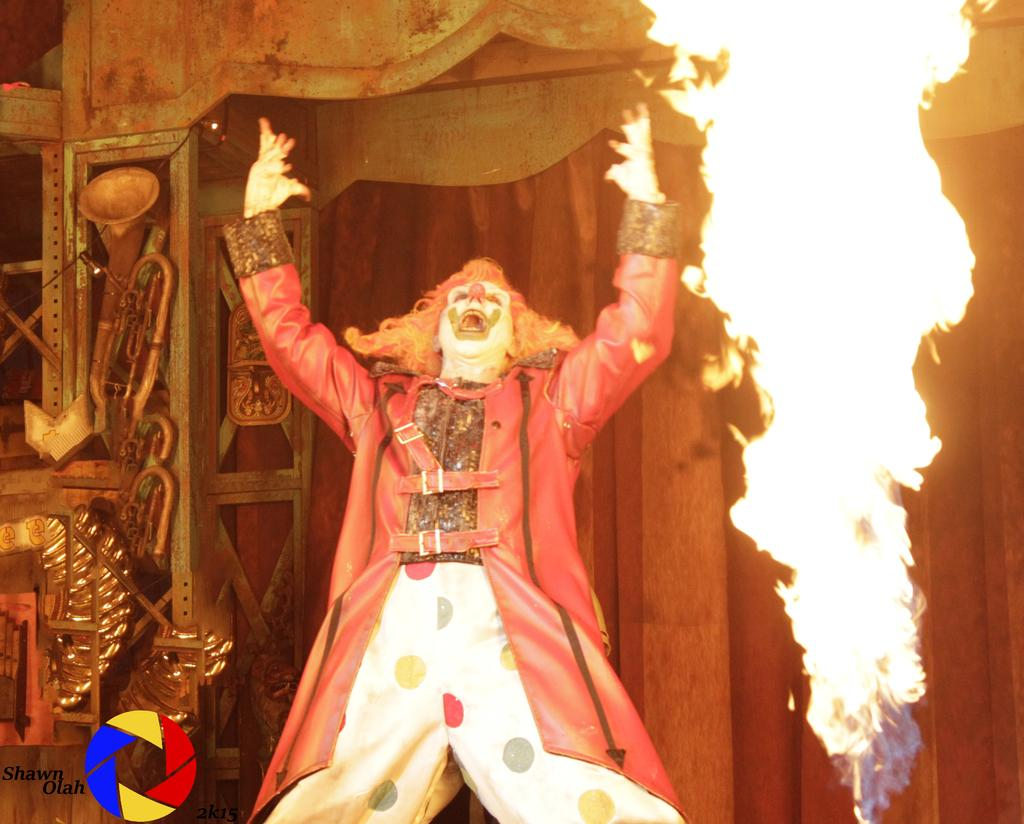Who is the main subject in the image? There is a man in the middle of the image. What is the man wearing? The man is wearing a costume. What is happening near the man? There is fire beside the man. What can be found in the bottom left corner of the image? There is some text and a logo in the bottom left corner of the image. How does the man contribute to reducing pollution in the image? The image does not show the man contributing to reducing pollution; it only shows him wearing a costume and standing near fire. 